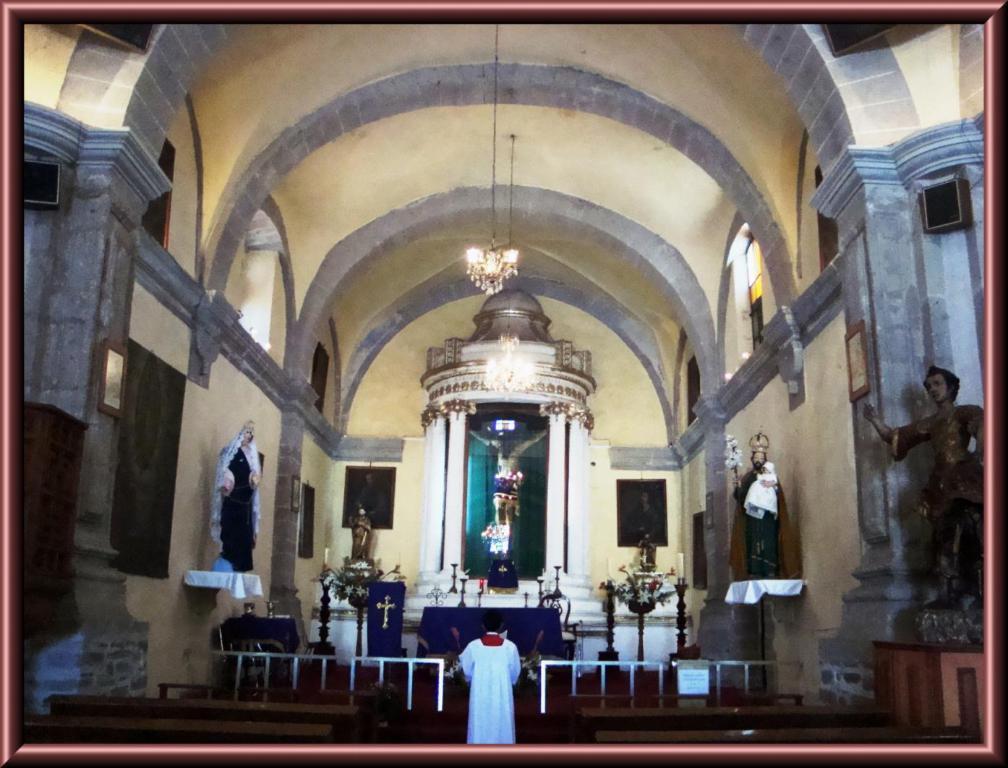Could you give a brief overview of what you see in this image? In the image we can see a frame. In the frame we can see some benches and a person. Behind the person there is a fencing and there are some statues. Top of the image there is roof and light. 